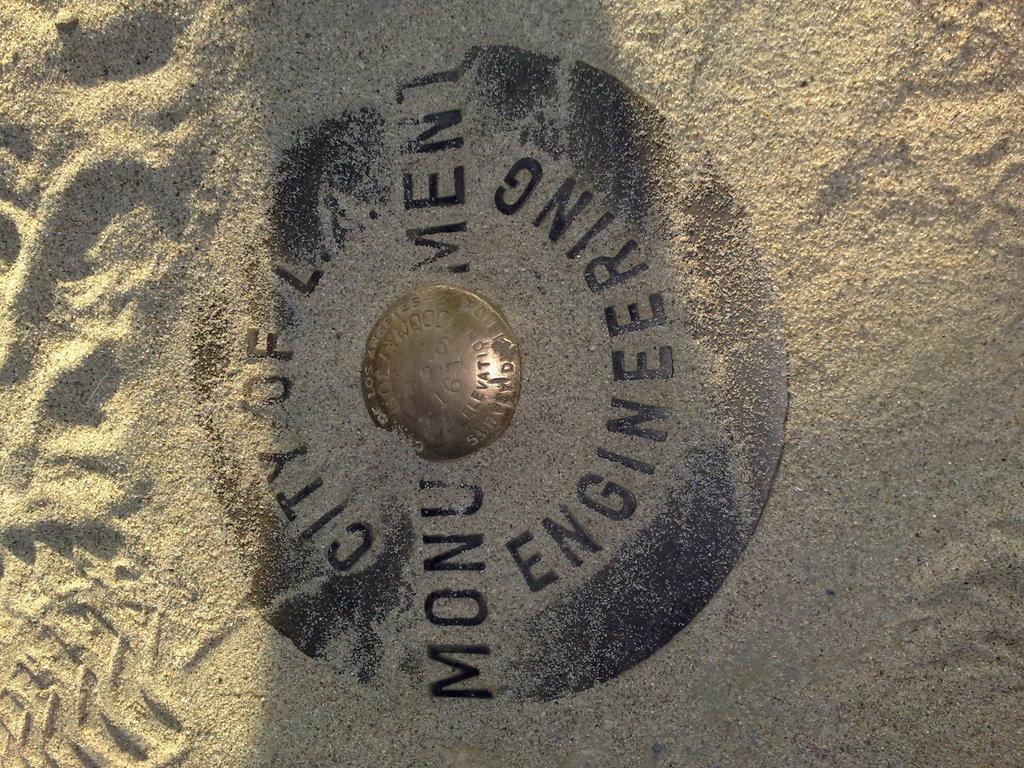What city is mentioned in the text?
Your answer should be very brief. L.a. Does the word engineering appear in the image?
Provide a short and direct response. Yes. 